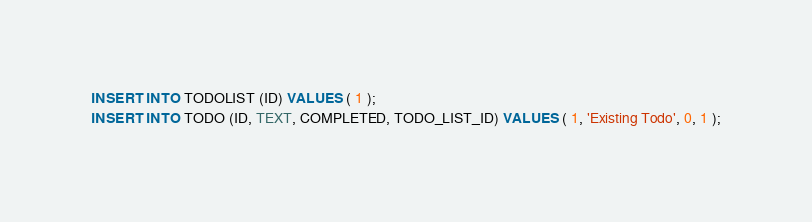<code> <loc_0><loc_0><loc_500><loc_500><_SQL_>INSERT INTO TODOLIST (ID) VALUES ( 1 );
INSERT INTO TODO (ID, TEXT, COMPLETED, TODO_LIST_ID) VALUES ( 1, 'Existing Todo', 0, 1 );
</code> 